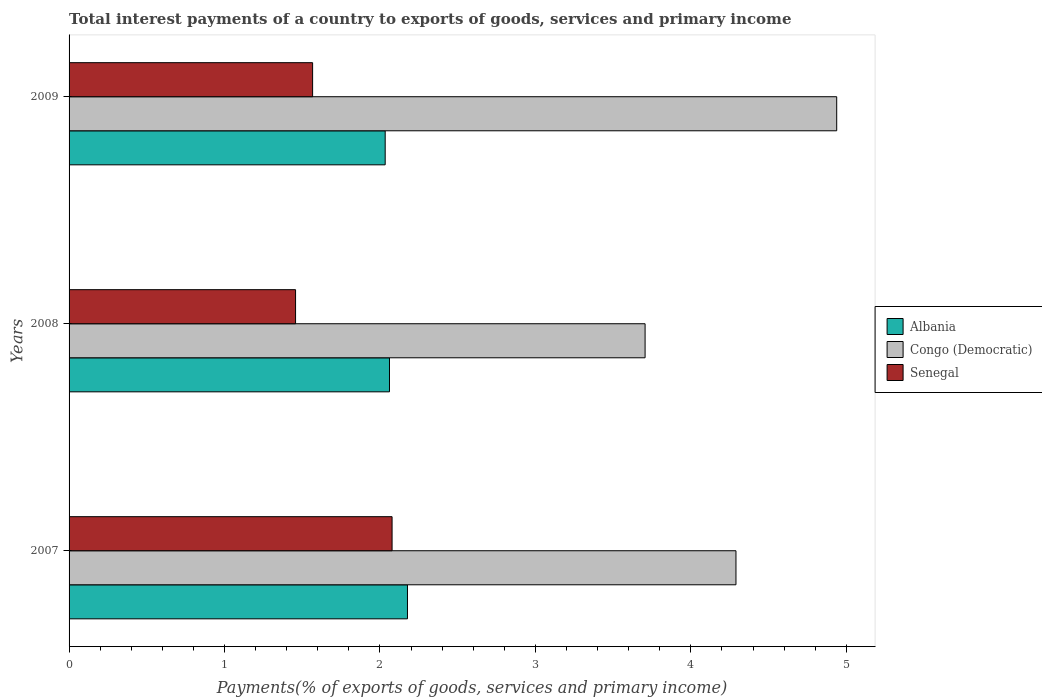Are the number of bars per tick equal to the number of legend labels?
Offer a terse response. Yes. Are the number of bars on each tick of the Y-axis equal?
Provide a short and direct response. Yes. How many bars are there on the 3rd tick from the bottom?
Your answer should be very brief. 3. In how many cases, is the number of bars for a given year not equal to the number of legend labels?
Make the answer very short. 0. What is the total interest payments in Senegal in 2008?
Your response must be concise. 1.46. Across all years, what is the maximum total interest payments in Senegal?
Make the answer very short. 2.08. Across all years, what is the minimum total interest payments in Congo (Democratic)?
Ensure brevity in your answer.  3.71. In which year was the total interest payments in Albania minimum?
Offer a very short reply. 2009. What is the total total interest payments in Senegal in the graph?
Your answer should be very brief. 5.1. What is the difference between the total interest payments in Senegal in 2007 and that in 2009?
Provide a succinct answer. 0.51. What is the difference between the total interest payments in Albania in 2009 and the total interest payments in Senegal in 2007?
Your answer should be compact. -0.04. What is the average total interest payments in Senegal per year?
Make the answer very short. 1.7. In the year 2009, what is the difference between the total interest payments in Senegal and total interest payments in Albania?
Offer a terse response. -0.47. In how many years, is the total interest payments in Albania greater than 2 %?
Your answer should be very brief. 3. What is the ratio of the total interest payments in Congo (Democratic) in 2007 to that in 2009?
Your response must be concise. 0.87. Is the difference between the total interest payments in Senegal in 2007 and 2008 greater than the difference between the total interest payments in Albania in 2007 and 2008?
Offer a very short reply. Yes. What is the difference between the highest and the second highest total interest payments in Senegal?
Your answer should be very brief. 0.51. What is the difference between the highest and the lowest total interest payments in Senegal?
Keep it short and to the point. 0.62. What does the 2nd bar from the top in 2008 represents?
Provide a succinct answer. Congo (Democratic). What does the 1st bar from the bottom in 2008 represents?
Provide a succinct answer. Albania. How many bars are there?
Provide a short and direct response. 9. What is the difference between two consecutive major ticks on the X-axis?
Provide a short and direct response. 1. Are the values on the major ticks of X-axis written in scientific E-notation?
Provide a short and direct response. No. How are the legend labels stacked?
Keep it short and to the point. Vertical. What is the title of the graph?
Offer a very short reply. Total interest payments of a country to exports of goods, services and primary income. What is the label or title of the X-axis?
Your answer should be very brief. Payments(% of exports of goods, services and primary income). What is the label or title of the Y-axis?
Keep it short and to the point. Years. What is the Payments(% of exports of goods, services and primary income) in Albania in 2007?
Give a very brief answer. 2.18. What is the Payments(% of exports of goods, services and primary income) of Congo (Democratic) in 2007?
Your response must be concise. 4.29. What is the Payments(% of exports of goods, services and primary income) of Senegal in 2007?
Keep it short and to the point. 2.08. What is the Payments(% of exports of goods, services and primary income) in Albania in 2008?
Provide a succinct answer. 2.06. What is the Payments(% of exports of goods, services and primary income) in Congo (Democratic) in 2008?
Your response must be concise. 3.71. What is the Payments(% of exports of goods, services and primary income) in Senegal in 2008?
Your answer should be compact. 1.46. What is the Payments(% of exports of goods, services and primary income) of Albania in 2009?
Your response must be concise. 2.03. What is the Payments(% of exports of goods, services and primary income) of Congo (Democratic) in 2009?
Provide a short and direct response. 4.94. What is the Payments(% of exports of goods, services and primary income) in Senegal in 2009?
Ensure brevity in your answer.  1.57. Across all years, what is the maximum Payments(% of exports of goods, services and primary income) in Albania?
Provide a succinct answer. 2.18. Across all years, what is the maximum Payments(% of exports of goods, services and primary income) in Congo (Democratic)?
Offer a terse response. 4.94. Across all years, what is the maximum Payments(% of exports of goods, services and primary income) in Senegal?
Your response must be concise. 2.08. Across all years, what is the minimum Payments(% of exports of goods, services and primary income) of Albania?
Your response must be concise. 2.03. Across all years, what is the minimum Payments(% of exports of goods, services and primary income) in Congo (Democratic)?
Provide a succinct answer. 3.71. Across all years, what is the minimum Payments(% of exports of goods, services and primary income) of Senegal?
Give a very brief answer. 1.46. What is the total Payments(% of exports of goods, services and primary income) in Albania in the graph?
Provide a short and direct response. 6.27. What is the total Payments(% of exports of goods, services and primary income) of Congo (Democratic) in the graph?
Offer a very short reply. 12.93. What is the total Payments(% of exports of goods, services and primary income) of Senegal in the graph?
Provide a short and direct response. 5.1. What is the difference between the Payments(% of exports of goods, services and primary income) in Albania in 2007 and that in 2008?
Offer a terse response. 0.12. What is the difference between the Payments(% of exports of goods, services and primary income) in Congo (Democratic) in 2007 and that in 2008?
Your answer should be compact. 0.58. What is the difference between the Payments(% of exports of goods, services and primary income) of Senegal in 2007 and that in 2008?
Make the answer very short. 0.62. What is the difference between the Payments(% of exports of goods, services and primary income) of Albania in 2007 and that in 2009?
Your answer should be compact. 0.14. What is the difference between the Payments(% of exports of goods, services and primary income) of Congo (Democratic) in 2007 and that in 2009?
Provide a succinct answer. -0.65. What is the difference between the Payments(% of exports of goods, services and primary income) of Senegal in 2007 and that in 2009?
Ensure brevity in your answer.  0.51. What is the difference between the Payments(% of exports of goods, services and primary income) of Albania in 2008 and that in 2009?
Your answer should be compact. 0.03. What is the difference between the Payments(% of exports of goods, services and primary income) of Congo (Democratic) in 2008 and that in 2009?
Offer a very short reply. -1.23. What is the difference between the Payments(% of exports of goods, services and primary income) in Senegal in 2008 and that in 2009?
Keep it short and to the point. -0.11. What is the difference between the Payments(% of exports of goods, services and primary income) in Albania in 2007 and the Payments(% of exports of goods, services and primary income) in Congo (Democratic) in 2008?
Your answer should be compact. -1.53. What is the difference between the Payments(% of exports of goods, services and primary income) of Albania in 2007 and the Payments(% of exports of goods, services and primary income) of Senegal in 2008?
Offer a terse response. 0.72. What is the difference between the Payments(% of exports of goods, services and primary income) of Congo (Democratic) in 2007 and the Payments(% of exports of goods, services and primary income) of Senegal in 2008?
Make the answer very short. 2.83. What is the difference between the Payments(% of exports of goods, services and primary income) of Albania in 2007 and the Payments(% of exports of goods, services and primary income) of Congo (Democratic) in 2009?
Give a very brief answer. -2.76. What is the difference between the Payments(% of exports of goods, services and primary income) in Albania in 2007 and the Payments(% of exports of goods, services and primary income) in Senegal in 2009?
Provide a short and direct response. 0.61. What is the difference between the Payments(% of exports of goods, services and primary income) of Congo (Democratic) in 2007 and the Payments(% of exports of goods, services and primary income) of Senegal in 2009?
Give a very brief answer. 2.72. What is the difference between the Payments(% of exports of goods, services and primary income) in Albania in 2008 and the Payments(% of exports of goods, services and primary income) in Congo (Democratic) in 2009?
Provide a succinct answer. -2.88. What is the difference between the Payments(% of exports of goods, services and primary income) in Albania in 2008 and the Payments(% of exports of goods, services and primary income) in Senegal in 2009?
Provide a short and direct response. 0.49. What is the difference between the Payments(% of exports of goods, services and primary income) of Congo (Democratic) in 2008 and the Payments(% of exports of goods, services and primary income) of Senegal in 2009?
Make the answer very short. 2.14. What is the average Payments(% of exports of goods, services and primary income) of Albania per year?
Make the answer very short. 2.09. What is the average Payments(% of exports of goods, services and primary income) in Congo (Democratic) per year?
Ensure brevity in your answer.  4.31. What is the average Payments(% of exports of goods, services and primary income) in Senegal per year?
Offer a terse response. 1.7. In the year 2007, what is the difference between the Payments(% of exports of goods, services and primary income) of Albania and Payments(% of exports of goods, services and primary income) of Congo (Democratic)?
Offer a terse response. -2.11. In the year 2007, what is the difference between the Payments(% of exports of goods, services and primary income) in Albania and Payments(% of exports of goods, services and primary income) in Senegal?
Provide a short and direct response. 0.1. In the year 2007, what is the difference between the Payments(% of exports of goods, services and primary income) in Congo (Democratic) and Payments(% of exports of goods, services and primary income) in Senegal?
Your answer should be very brief. 2.21. In the year 2008, what is the difference between the Payments(% of exports of goods, services and primary income) of Albania and Payments(% of exports of goods, services and primary income) of Congo (Democratic)?
Make the answer very short. -1.64. In the year 2008, what is the difference between the Payments(% of exports of goods, services and primary income) in Albania and Payments(% of exports of goods, services and primary income) in Senegal?
Provide a short and direct response. 0.6. In the year 2008, what is the difference between the Payments(% of exports of goods, services and primary income) in Congo (Democratic) and Payments(% of exports of goods, services and primary income) in Senegal?
Keep it short and to the point. 2.25. In the year 2009, what is the difference between the Payments(% of exports of goods, services and primary income) in Albania and Payments(% of exports of goods, services and primary income) in Congo (Democratic)?
Ensure brevity in your answer.  -2.9. In the year 2009, what is the difference between the Payments(% of exports of goods, services and primary income) of Albania and Payments(% of exports of goods, services and primary income) of Senegal?
Your answer should be compact. 0.47. In the year 2009, what is the difference between the Payments(% of exports of goods, services and primary income) of Congo (Democratic) and Payments(% of exports of goods, services and primary income) of Senegal?
Give a very brief answer. 3.37. What is the ratio of the Payments(% of exports of goods, services and primary income) of Albania in 2007 to that in 2008?
Offer a very short reply. 1.06. What is the ratio of the Payments(% of exports of goods, services and primary income) in Congo (Democratic) in 2007 to that in 2008?
Keep it short and to the point. 1.16. What is the ratio of the Payments(% of exports of goods, services and primary income) in Senegal in 2007 to that in 2008?
Provide a short and direct response. 1.43. What is the ratio of the Payments(% of exports of goods, services and primary income) of Albania in 2007 to that in 2009?
Offer a terse response. 1.07. What is the ratio of the Payments(% of exports of goods, services and primary income) in Congo (Democratic) in 2007 to that in 2009?
Keep it short and to the point. 0.87. What is the ratio of the Payments(% of exports of goods, services and primary income) of Senegal in 2007 to that in 2009?
Provide a short and direct response. 1.33. What is the ratio of the Payments(% of exports of goods, services and primary income) in Albania in 2008 to that in 2009?
Give a very brief answer. 1.01. What is the ratio of the Payments(% of exports of goods, services and primary income) in Congo (Democratic) in 2008 to that in 2009?
Your answer should be very brief. 0.75. What is the difference between the highest and the second highest Payments(% of exports of goods, services and primary income) of Albania?
Give a very brief answer. 0.12. What is the difference between the highest and the second highest Payments(% of exports of goods, services and primary income) of Congo (Democratic)?
Offer a terse response. 0.65. What is the difference between the highest and the second highest Payments(% of exports of goods, services and primary income) of Senegal?
Keep it short and to the point. 0.51. What is the difference between the highest and the lowest Payments(% of exports of goods, services and primary income) of Albania?
Your answer should be very brief. 0.14. What is the difference between the highest and the lowest Payments(% of exports of goods, services and primary income) in Congo (Democratic)?
Give a very brief answer. 1.23. What is the difference between the highest and the lowest Payments(% of exports of goods, services and primary income) in Senegal?
Make the answer very short. 0.62. 